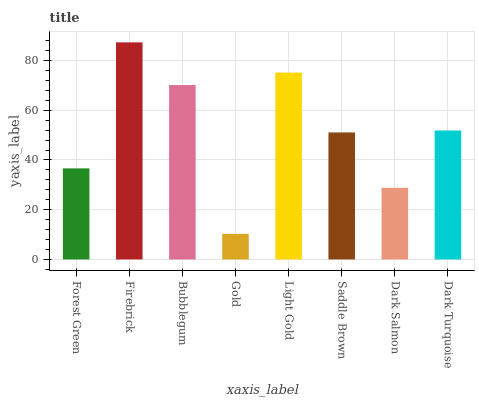Is Gold the minimum?
Answer yes or no. Yes. Is Firebrick the maximum?
Answer yes or no. Yes. Is Bubblegum the minimum?
Answer yes or no. No. Is Bubblegum the maximum?
Answer yes or no. No. Is Firebrick greater than Bubblegum?
Answer yes or no. Yes. Is Bubblegum less than Firebrick?
Answer yes or no. Yes. Is Bubblegum greater than Firebrick?
Answer yes or no. No. Is Firebrick less than Bubblegum?
Answer yes or no. No. Is Dark Turquoise the high median?
Answer yes or no. Yes. Is Saddle Brown the low median?
Answer yes or no. Yes. Is Dark Salmon the high median?
Answer yes or no. No. Is Forest Green the low median?
Answer yes or no. No. 